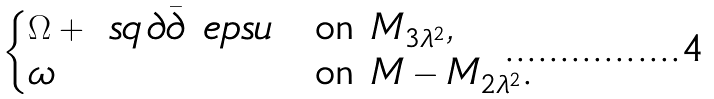Convert formula to latex. <formula><loc_0><loc_0><loc_500><loc_500>\begin{cases} \Omega + \ s q \, \partial \bar { \partial } \ e p s u & \text {on $M_{3\lambda^{2}}$} , \\ \omega & \text {on $M-M_{2\lambda^{2}}$.} \end{cases}</formula> 